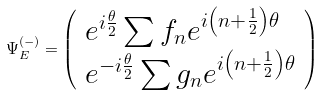<formula> <loc_0><loc_0><loc_500><loc_500>\Psi _ { E } ^ { ( - ) } = \left ( \begin{array} { l } e ^ { i \frac { \theta } { 2 } } \sum f _ { n } e ^ { i \left ( n + \frac { 1 } { 2 } \right ) \theta } \\ e ^ { - i \frac { \theta } { 2 } } \sum g _ { n } e ^ { i \left ( n + \frac { 1 } { 2 } \right ) \theta } \end{array} \right )</formula> 